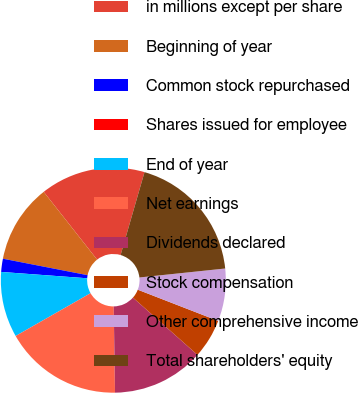<chart> <loc_0><loc_0><loc_500><loc_500><pie_chart><fcel>in millions except per share<fcel>Beginning of year<fcel>Common stock repurchased<fcel>Shares issued for employee<fcel>End of year<fcel>Net earnings<fcel>Dividends declared<fcel>Stock compensation<fcel>Other comprehensive income<fcel>Total shareholders' equity<nl><fcel>15.09%<fcel>11.32%<fcel>1.89%<fcel>0.0%<fcel>9.43%<fcel>16.98%<fcel>13.21%<fcel>5.66%<fcel>7.55%<fcel>18.87%<nl></chart> 